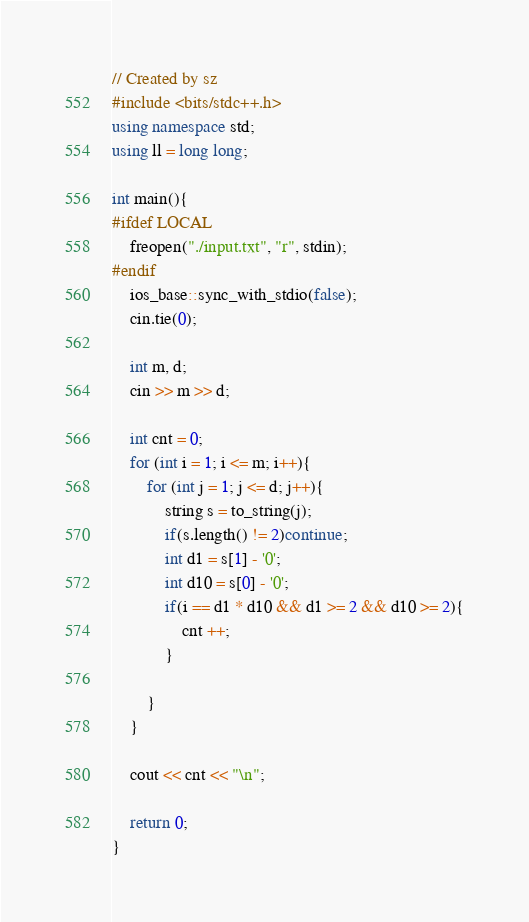<code> <loc_0><loc_0><loc_500><loc_500><_C++_>// Created by sz
#include <bits/stdc++.h>
using namespace std;
using ll = long long;

int main(){
#ifdef LOCAL
    freopen("./input.txt", "r", stdin);
#endif
    ios_base::sync_with_stdio(false);
    cin.tie(0);
    
    int m, d;
    cin >> m >> d;
    
    int cnt = 0;
    for (int i = 1; i <= m; i++){
        for (int j = 1; j <= d; j++){
            string s = to_string(j);
            if(s.length() != 2)continue;
            int d1 = s[1] - '0';
            int d10 = s[0] - '0';
            if(i == d1 * d10 && d1 >= 2 && d10 >= 2){
                cnt ++;
            }
            
        }
    }
    
    cout << cnt << "\n";
    
    return 0;
}
</code> 